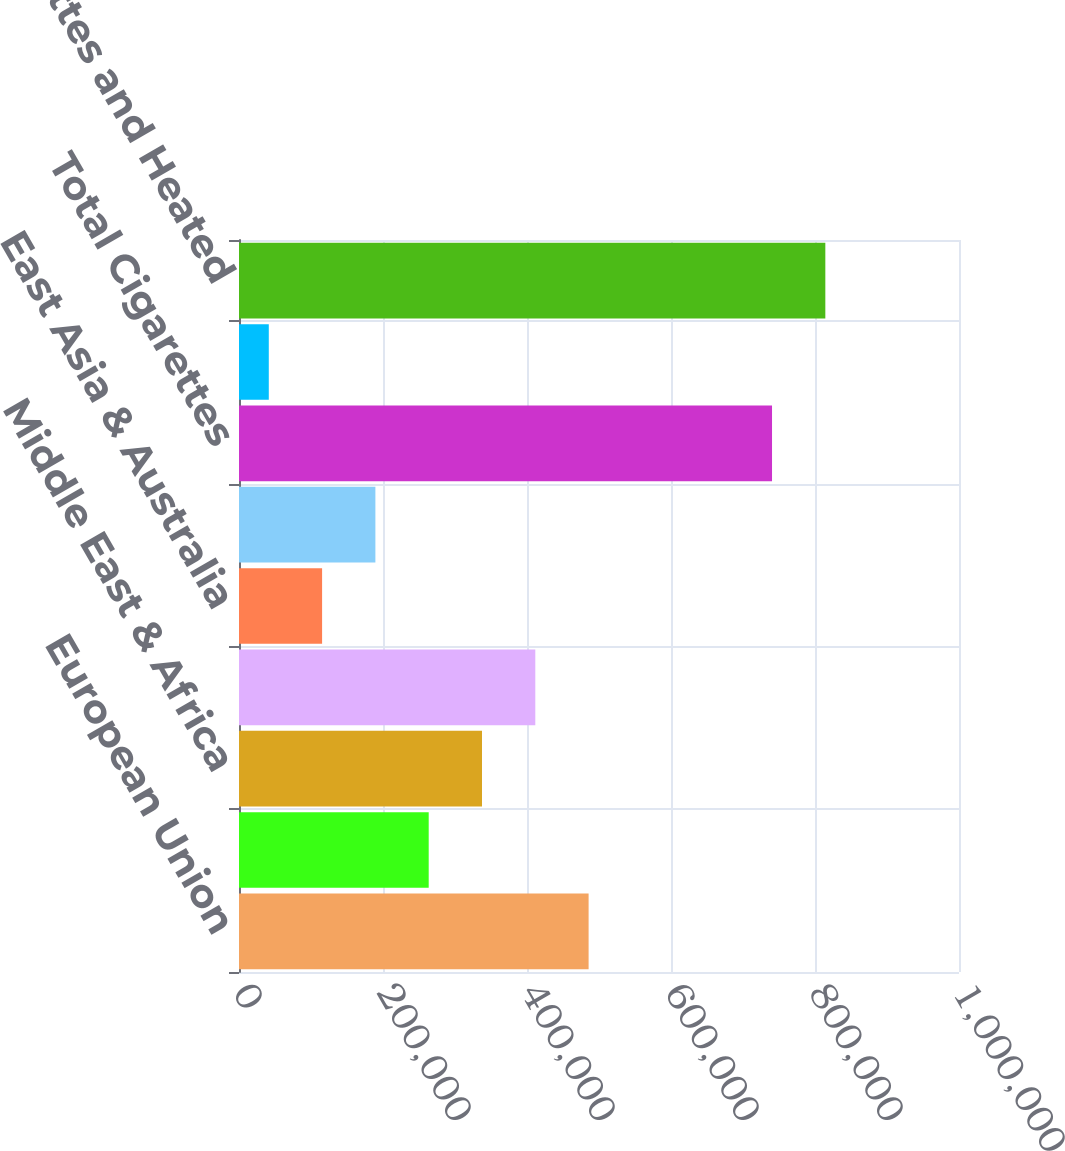Convert chart to OTSL. <chart><loc_0><loc_0><loc_500><loc_500><bar_chart><fcel>European Union<fcel>Eastern Europe<fcel>Middle East & Africa<fcel>South & Southeast Asia<fcel>East Asia & Australia<fcel>Latin America & Canada<fcel>Total Cigarettes<fcel>Total Heated Tobacco Units<fcel>Total Cigarettes and Heated<nl><fcel>485561<fcel>263466<fcel>337498<fcel>411530<fcel>115404<fcel>189435<fcel>740315<fcel>41372<fcel>814346<nl></chart> 